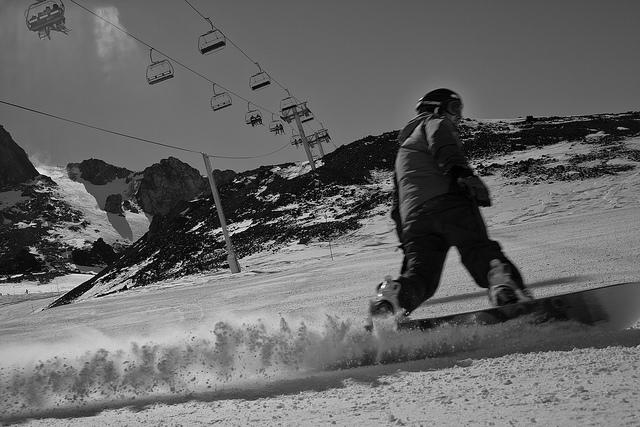How many people are snowboarding?
Keep it brief. 1. Is he sitting down?
Give a very brief answer. No. Is this snowboarder wearing a helmet?
Quick response, please. Yes. Is the man snowboarding?
Keep it brief. Yes. What is on the ground?
Concise answer only. Snow. What activity is the boy engaging in?
Write a very short answer. Snowboarding. How many empty cars are on the ski lift?
Quick response, please. 6. Is the man moving uphill?
Keep it brief. No. Is the person smiling?
Concise answer only. No. What is the guy standing on?
Give a very brief answer. Snowboard. When was this picture taken?
Concise answer only. Winter. Is this person sliding?
Be succinct. Yes. What color is the board?
Short answer required. White. How many people are on the chairlift?
Be succinct. 8. What activity are these people engaging in?
Write a very short answer. Snowboarding. What activity are they participating in?
Answer briefly. Snowboarding. 